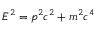Convert formula to latex. <formula><loc_0><loc_0><loc_500><loc_500>E ^ { 2 } = p ^ { 2 } c ^ { 2 } + m ^ { 2 } c ^ { 4 }</formula> 